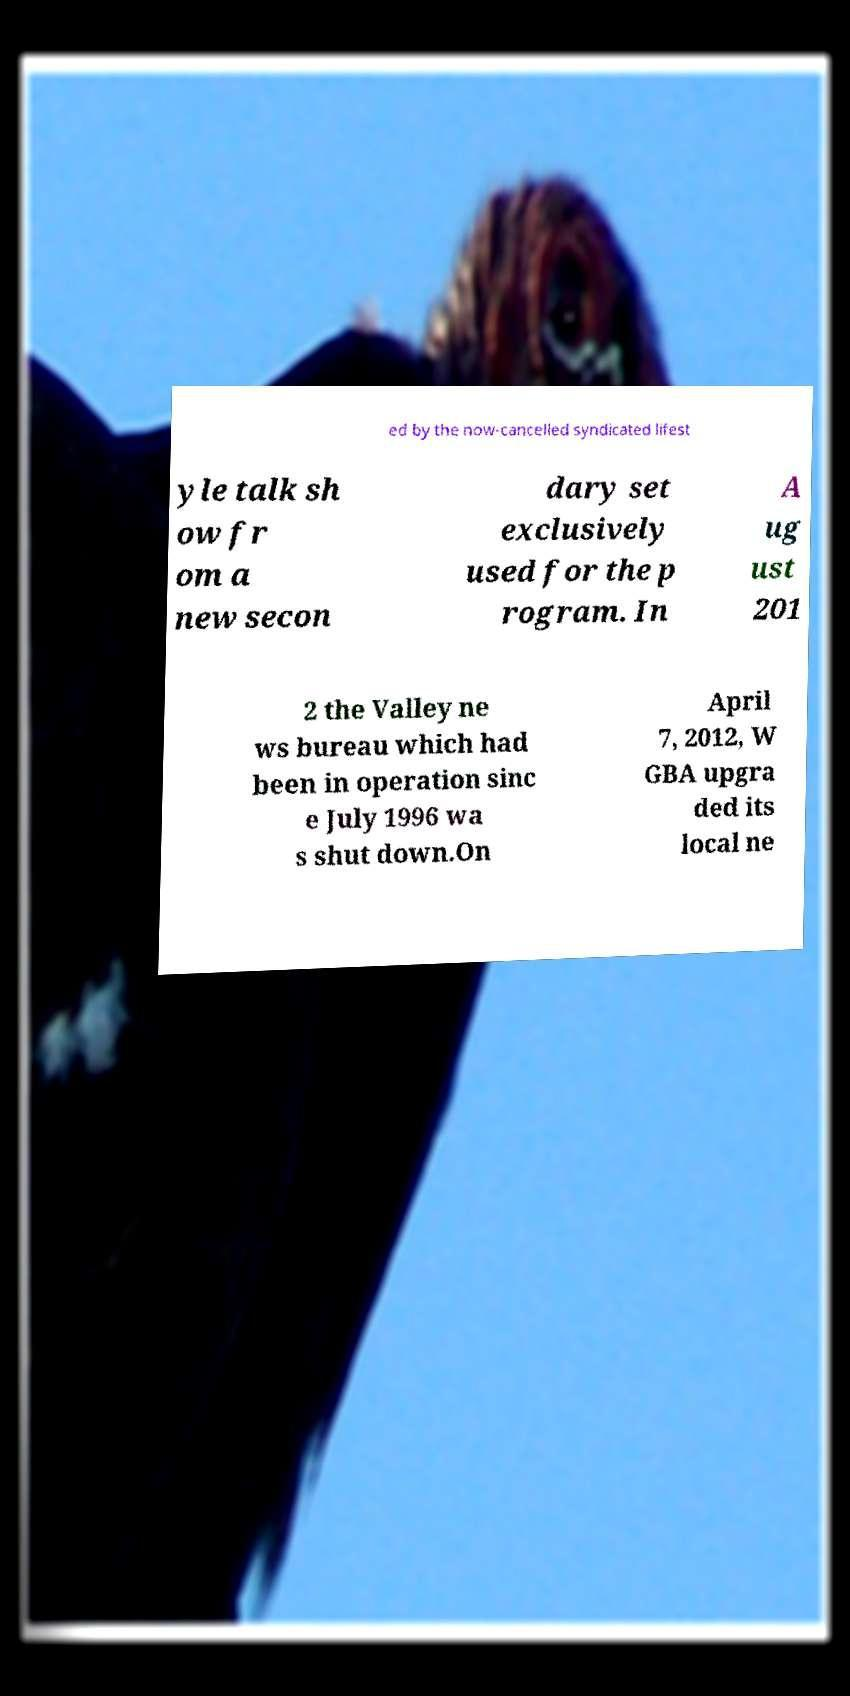Please identify and transcribe the text found in this image. ed by the now-cancelled syndicated lifest yle talk sh ow fr om a new secon dary set exclusively used for the p rogram. In A ug ust 201 2 the Valley ne ws bureau which had been in operation sinc e July 1996 wa s shut down.On April 7, 2012, W GBA upgra ded its local ne 